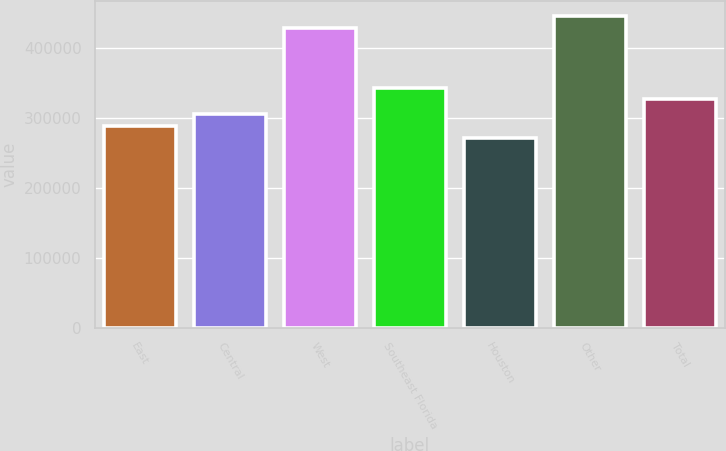Convert chart. <chart><loc_0><loc_0><loc_500><loc_500><bar_chart><fcel>East<fcel>Central<fcel>West<fcel>Southeast Florida<fcel>Houston<fcel>Other<fcel>Total<nl><fcel>288800<fcel>305600<fcel>429000<fcel>343800<fcel>272000<fcel>445800<fcel>327000<nl></chart> 